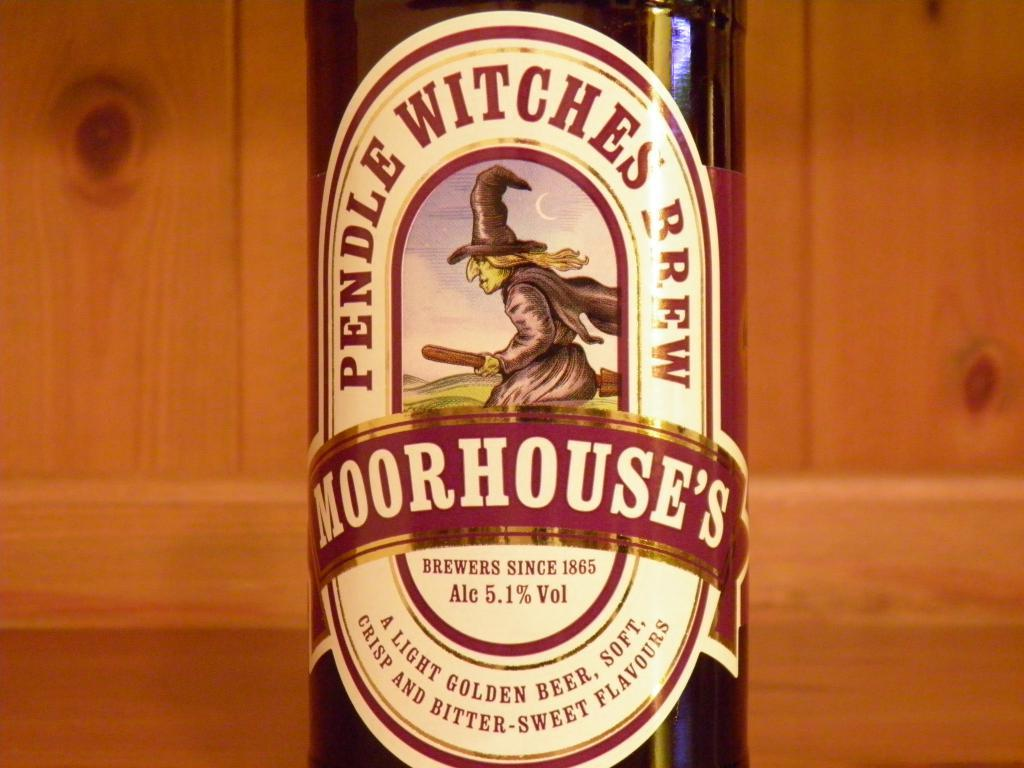<image>
Render a clear and concise summary of the photo. a close up of the label for MoorHouse's Pendle Witches Brew 